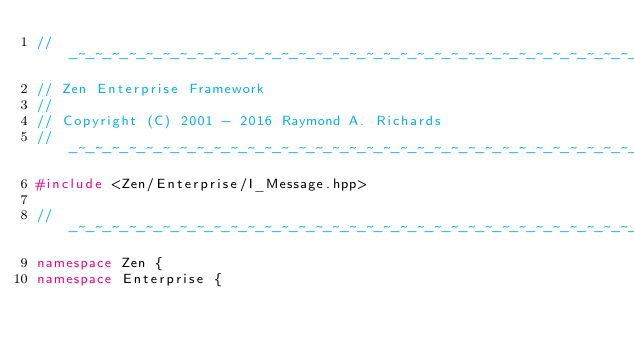Convert code to text. <code><loc_0><loc_0><loc_500><loc_500><_C++_>//-~-~-~-~-~-~-~-~-~-~-~-~-~-~-~-~-~-~-~-~-~-~-~-~-~-~-~-~-~-~-~-~-~-~-~-~-~-~-~
// Zen Enterprise Framework
//
// Copyright (C) 2001 - 2016 Raymond A. Richards
//-~-~-~-~-~-~-~-~-~-~-~-~-~-~-~-~-~-~-~-~-~-~-~-~-~-~-~-~-~-~-~-~-~-~-~-~-~-~-~
#include <Zen/Enterprise/I_Message.hpp>

//-~-~-~-~-~-~-~-~-~-~-~-~-~-~-~-~-~-~-~-~-~-~-~-~-~-~-~-~-~-~-~-~-~-~-~-~-~-~-~
namespace Zen {
namespace Enterprise {</code> 